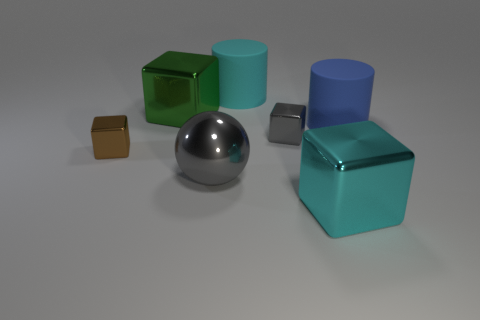Add 2 large rubber things. How many objects exist? 9 Subtract all cubes. How many objects are left? 3 Add 6 brown shiny things. How many brown shiny things are left? 7 Add 2 large red spheres. How many large red spheres exist? 2 Subtract 1 gray spheres. How many objects are left? 6 Subtract all green metal blocks. Subtract all small metal things. How many objects are left? 4 